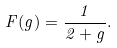Convert formula to latex. <formula><loc_0><loc_0><loc_500><loc_500>F ( g ) = \frac { 1 } { 2 + g } .</formula> 